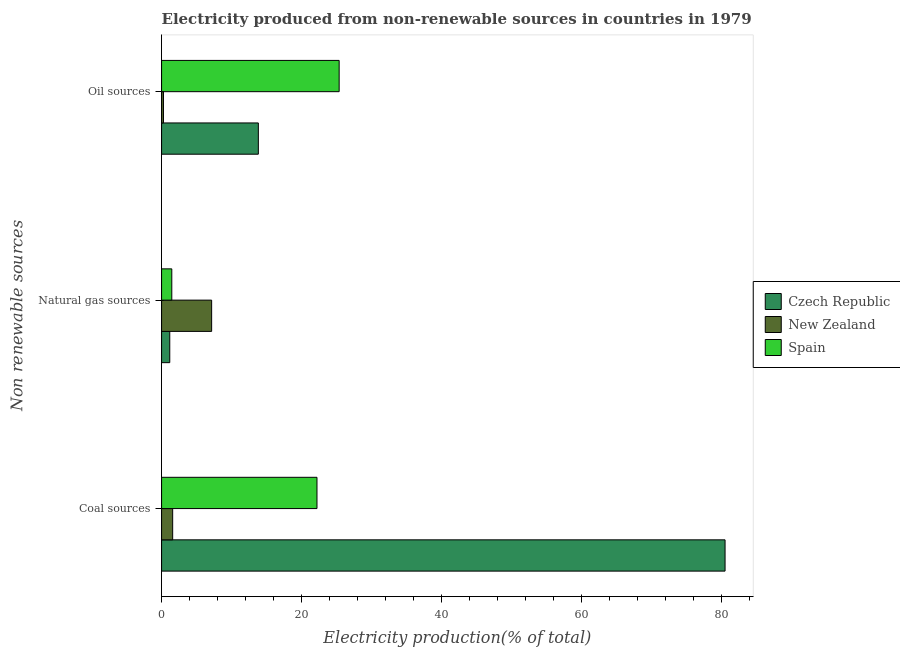Are the number of bars per tick equal to the number of legend labels?
Your response must be concise. Yes. How many bars are there on the 1st tick from the top?
Keep it short and to the point. 3. What is the label of the 2nd group of bars from the top?
Your answer should be compact. Natural gas sources. What is the percentage of electricity produced by natural gas in New Zealand?
Make the answer very short. 7.16. Across all countries, what is the maximum percentage of electricity produced by coal?
Offer a terse response. 80.53. Across all countries, what is the minimum percentage of electricity produced by oil sources?
Your answer should be compact. 0.27. In which country was the percentage of electricity produced by coal maximum?
Your response must be concise. Czech Republic. In which country was the percentage of electricity produced by coal minimum?
Your response must be concise. New Zealand. What is the total percentage of electricity produced by oil sources in the graph?
Make the answer very short. 39.48. What is the difference between the percentage of electricity produced by natural gas in Spain and that in New Zealand?
Your answer should be compact. -5.69. What is the difference between the percentage of electricity produced by oil sources in Czech Republic and the percentage of electricity produced by coal in Spain?
Make the answer very short. -8.38. What is the average percentage of electricity produced by natural gas per country?
Provide a succinct answer. 3.26. What is the difference between the percentage of electricity produced by coal and percentage of electricity produced by oil sources in Czech Republic?
Your answer should be very brief. 66.7. What is the ratio of the percentage of electricity produced by natural gas in New Zealand to that in Czech Republic?
Your response must be concise. 6.11. Is the difference between the percentage of electricity produced by oil sources in Czech Republic and Spain greater than the difference between the percentage of electricity produced by coal in Czech Republic and Spain?
Provide a succinct answer. No. What is the difference between the highest and the second highest percentage of electricity produced by oil sources?
Your answer should be very brief. 11.55. What is the difference between the highest and the lowest percentage of electricity produced by oil sources?
Keep it short and to the point. 25.11. What does the 3rd bar from the top in Coal sources represents?
Provide a short and direct response. Czech Republic. What does the 2nd bar from the bottom in Natural gas sources represents?
Offer a terse response. New Zealand. Are all the bars in the graph horizontal?
Your answer should be compact. Yes. How many countries are there in the graph?
Your answer should be very brief. 3. What is the difference between two consecutive major ticks on the X-axis?
Provide a short and direct response. 20. Does the graph contain any zero values?
Make the answer very short. No. Does the graph contain grids?
Provide a succinct answer. No. Where does the legend appear in the graph?
Make the answer very short. Center right. How many legend labels are there?
Your response must be concise. 3. How are the legend labels stacked?
Your answer should be very brief. Vertical. What is the title of the graph?
Your response must be concise. Electricity produced from non-renewable sources in countries in 1979. What is the label or title of the Y-axis?
Provide a succinct answer. Non renewable sources. What is the Electricity production(% of total) of Czech Republic in Coal sources?
Your answer should be very brief. 80.53. What is the Electricity production(% of total) in New Zealand in Coal sources?
Ensure brevity in your answer.  1.59. What is the Electricity production(% of total) of Spain in Coal sources?
Your response must be concise. 22.21. What is the Electricity production(% of total) of Czech Republic in Natural gas sources?
Keep it short and to the point. 1.17. What is the Electricity production(% of total) in New Zealand in Natural gas sources?
Offer a very short reply. 7.16. What is the Electricity production(% of total) in Spain in Natural gas sources?
Make the answer very short. 1.46. What is the Electricity production(% of total) of Czech Republic in Oil sources?
Keep it short and to the point. 13.83. What is the Electricity production(% of total) in New Zealand in Oil sources?
Make the answer very short. 0.27. What is the Electricity production(% of total) in Spain in Oil sources?
Ensure brevity in your answer.  25.38. Across all Non renewable sources, what is the maximum Electricity production(% of total) in Czech Republic?
Offer a very short reply. 80.53. Across all Non renewable sources, what is the maximum Electricity production(% of total) of New Zealand?
Provide a succinct answer. 7.16. Across all Non renewable sources, what is the maximum Electricity production(% of total) of Spain?
Your answer should be compact. 25.38. Across all Non renewable sources, what is the minimum Electricity production(% of total) of Czech Republic?
Keep it short and to the point. 1.17. Across all Non renewable sources, what is the minimum Electricity production(% of total) in New Zealand?
Give a very brief answer. 0.27. Across all Non renewable sources, what is the minimum Electricity production(% of total) of Spain?
Ensure brevity in your answer.  1.46. What is the total Electricity production(% of total) of Czech Republic in the graph?
Your answer should be very brief. 95.53. What is the total Electricity production(% of total) in New Zealand in the graph?
Keep it short and to the point. 9.01. What is the total Electricity production(% of total) of Spain in the graph?
Your answer should be very brief. 49.05. What is the difference between the Electricity production(% of total) in Czech Republic in Coal sources and that in Natural gas sources?
Offer a very short reply. 79.36. What is the difference between the Electricity production(% of total) in New Zealand in Coal sources and that in Natural gas sources?
Your answer should be very brief. -5.57. What is the difference between the Electricity production(% of total) of Spain in Coal sources and that in Natural gas sources?
Keep it short and to the point. 20.75. What is the difference between the Electricity production(% of total) in Czech Republic in Coal sources and that in Oil sources?
Your answer should be compact. 66.7. What is the difference between the Electricity production(% of total) of New Zealand in Coal sources and that in Oil sources?
Ensure brevity in your answer.  1.31. What is the difference between the Electricity production(% of total) in Spain in Coal sources and that in Oil sources?
Your answer should be very brief. -3.17. What is the difference between the Electricity production(% of total) in Czech Republic in Natural gas sources and that in Oil sources?
Offer a very short reply. -12.66. What is the difference between the Electricity production(% of total) of New Zealand in Natural gas sources and that in Oil sources?
Provide a succinct answer. 6.88. What is the difference between the Electricity production(% of total) of Spain in Natural gas sources and that in Oil sources?
Your answer should be compact. -23.92. What is the difference between the Electricity production(% of total) of Czech Republic in Coal sources and the Electricity production(% of total) of New Zealand in Natural gas sources?
Keep it short and to the point. 73.37. What is the difference between the Electricity production(% of total) of Czech Republic in Coal sources and the Electricity production(% of total) of Spain in Natural gas sources?
Provide a succinct answer. 79.07. What is the difference between the Electricity production(% of total) in New Zealand in Coal sources and the Electricity production(% of total) in Spain in Natural gas sources?
Your answer should be very brief. 0.12. What is the difference between the Electricity production(% of total) in Czech Republic in Coal sources and the Electricity production(% of total) in New Zealand in Oil sources?
Your answer should be very brief. 80.25. What is the difference between the Electricity production(% of total) of Czech Republic in Coal sources and the Electricity production(% of total) of Spain in Oil sources?
Your answer should be very brief. 55.15. What is the difference between the Electricity production(% of total) of New Zealand in Coal sources and the Electricity production(% of total) of Spain in Oil sources?
Offer a terse response. -23.79. What is the difference between the Electricity production(% of total) of Czech Republic in Natural gas sources and the Electricity production(% of total) of New Zealand in Oil sources?
Your answer should be compact. 0.9. What is the difference between the Electricity production(% of total) in Czech Republic in Natural gas sources and the Electricity production(% of total) in Spain in Oil sources?
Your response must be concise. -24.21. What is the difference between the Electricity production(% of total) in New Zealand in Natural gas sources and the Electricity production(% of total) in Spain in Oil sources?
Your answer should be very brief. -18.22. What is the average Electricity production(% of total) in Czech Republic per Non renewable sources?
Keep it short and to the point. 31.84. What is the average Electricity production(% of total) of New Zealand per Non renewable sources?
Provide a succinct answer. 3. What is the average Electricity production(% of total) of Spain per Non renewable sources?
Your response must be concise. 16.35. What is the difference between the Electricity production(% of total) of Czech Republic and Electricity production(% of total) of New Zealand in Coal sources?
Make the answer very short. 78.94. What is the difference between the Electricity production(% of total) in Czech Republic and Electricity production(% of total) in Spain in Coal sources?
Your answer should be compact. 58.32. What is the difference between the Electricity production(% of total) of New Zealand and Electricity production(% of total) of Spain in Coal sources?
Offer a terse response. -20.62. What is the difference between the Electricity production(% of total) in Czech Republic and Electricity production(% of total) in New Zealand in Natural gas sources?
Offer a terse response. -5.98. What is the difference between the Electricity production(% of total) in Czech Republic and Electricity production(% of total) in Spain in Natural gas sources?
Provide a succinct answer. -0.29. What is the difference between the Electricity production(% of total) of New Zealand and Electricity production(% of total) of Spain in Natural gas sources?
Give a very brief answer. 5.69. What is the difference between the Electricity production(% of total) of Czech Republic and Electricity production(% of total) of New Zealand in Oil sources?
Make the answer very short. 13.56. What is the difference between the Electricity production(% of total) of Czech Republic and Electricity production(% of total) of Spain in Oil sources?
Provide a succinct answer. -11.55. What is the difference between the Electricity production(% of total) in New Zealand and Electricity production(% of total) in Spain in Oil sources?
Provide a succinct answer. -25.11. What is the ratio of the Electricity production(% of total) in Czech Republic in Coal sources to that in Natural gas sources?
Your answer should be compact. 68.78. What is the ratio of the Electricity production(% of total) in New Zealand in Coal sources to that in Natural gas sources?
Provide a short and direct response. 0.22. What is the ratio of the Electricity production(% of total) of Spain in Coal sources to that in Natural gas sources?
Your response must be concise. 15.2. What is the ratio of the Electricity production(% of total) of Czech Republic in Coal sources to that in Oil sources?
Your answer should be compact. 5.82. What is the ratio of the Electricity production(% of total) of New Zealand in Coal sources to that in Oil sources?
Your answer should be very brief. 5.83. What is the ratio of the Electricity production(% of total) of Spain in Coal sources to that in Oil sources?
Make the answer very short. 0.88. What is the ratio of the Electricity production(% of total) of Czech Republic in Natural gas sources to that in Oil sources?
Make the answer very short. 0.08. What is the ratio of the Electricity production(% of total) in New Zealand in Natural gas sources to that in Oil sources?
Provide a succinct answer. 26.33. What is the ratio of the Electricity production(% of total) in Spain in Natural gas sources to that in Oil sources?
Ensure brevity in your answer.  0.06. What is the difference between the highest and the second highest Electricity production(% of total) in Czech Republic?
Keep it short and to the point. 66.7. What is the difference between the highest and the second highest Electricity production(% of total) in New Zealand?
Provide a short and direct response. 5.57. What is the difference between the highest and the second highest Electricity production(% of total) of Spain?
Offer a very short reply. 3.17. What is the difference between the highest and the lowest Electricity production(% of total) of Czech Republic?
Your response must be concise. 79.36. What is the difference between the highest and the lowest Electricity production(% of total) of New Zealand?
Ensure brevity in your answer.  6.88. What is the difference between the highest and the lowest Electricity production(% of total) of Spain?
Ensure brevity in your answer.  23.92. 